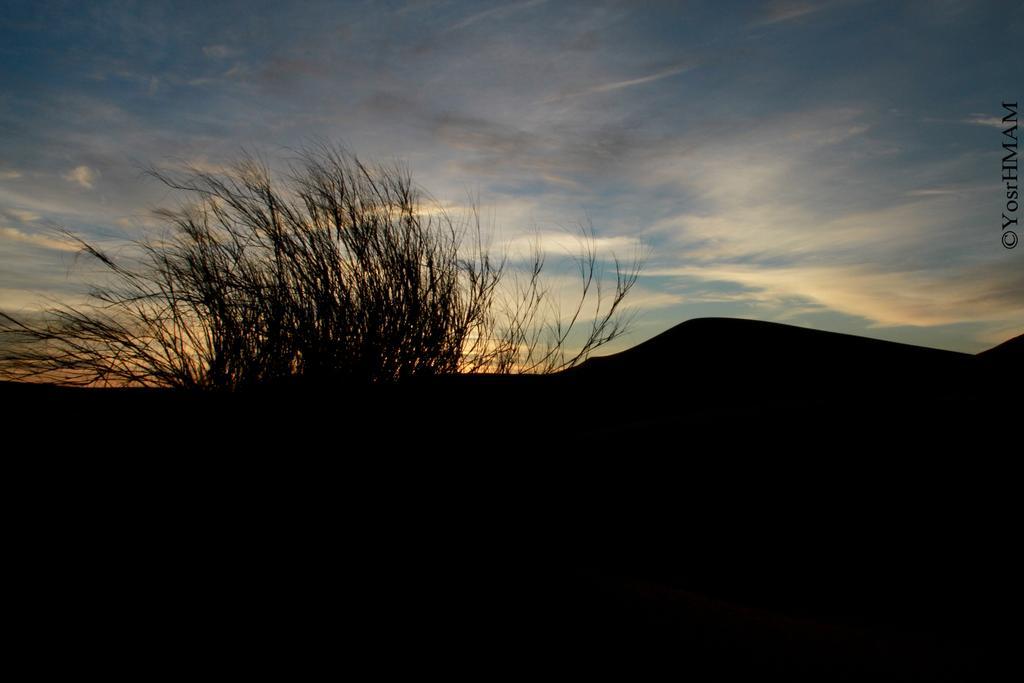Can you describe this image briefly? There are bushes in the middle of this image and the sky is in the background. 